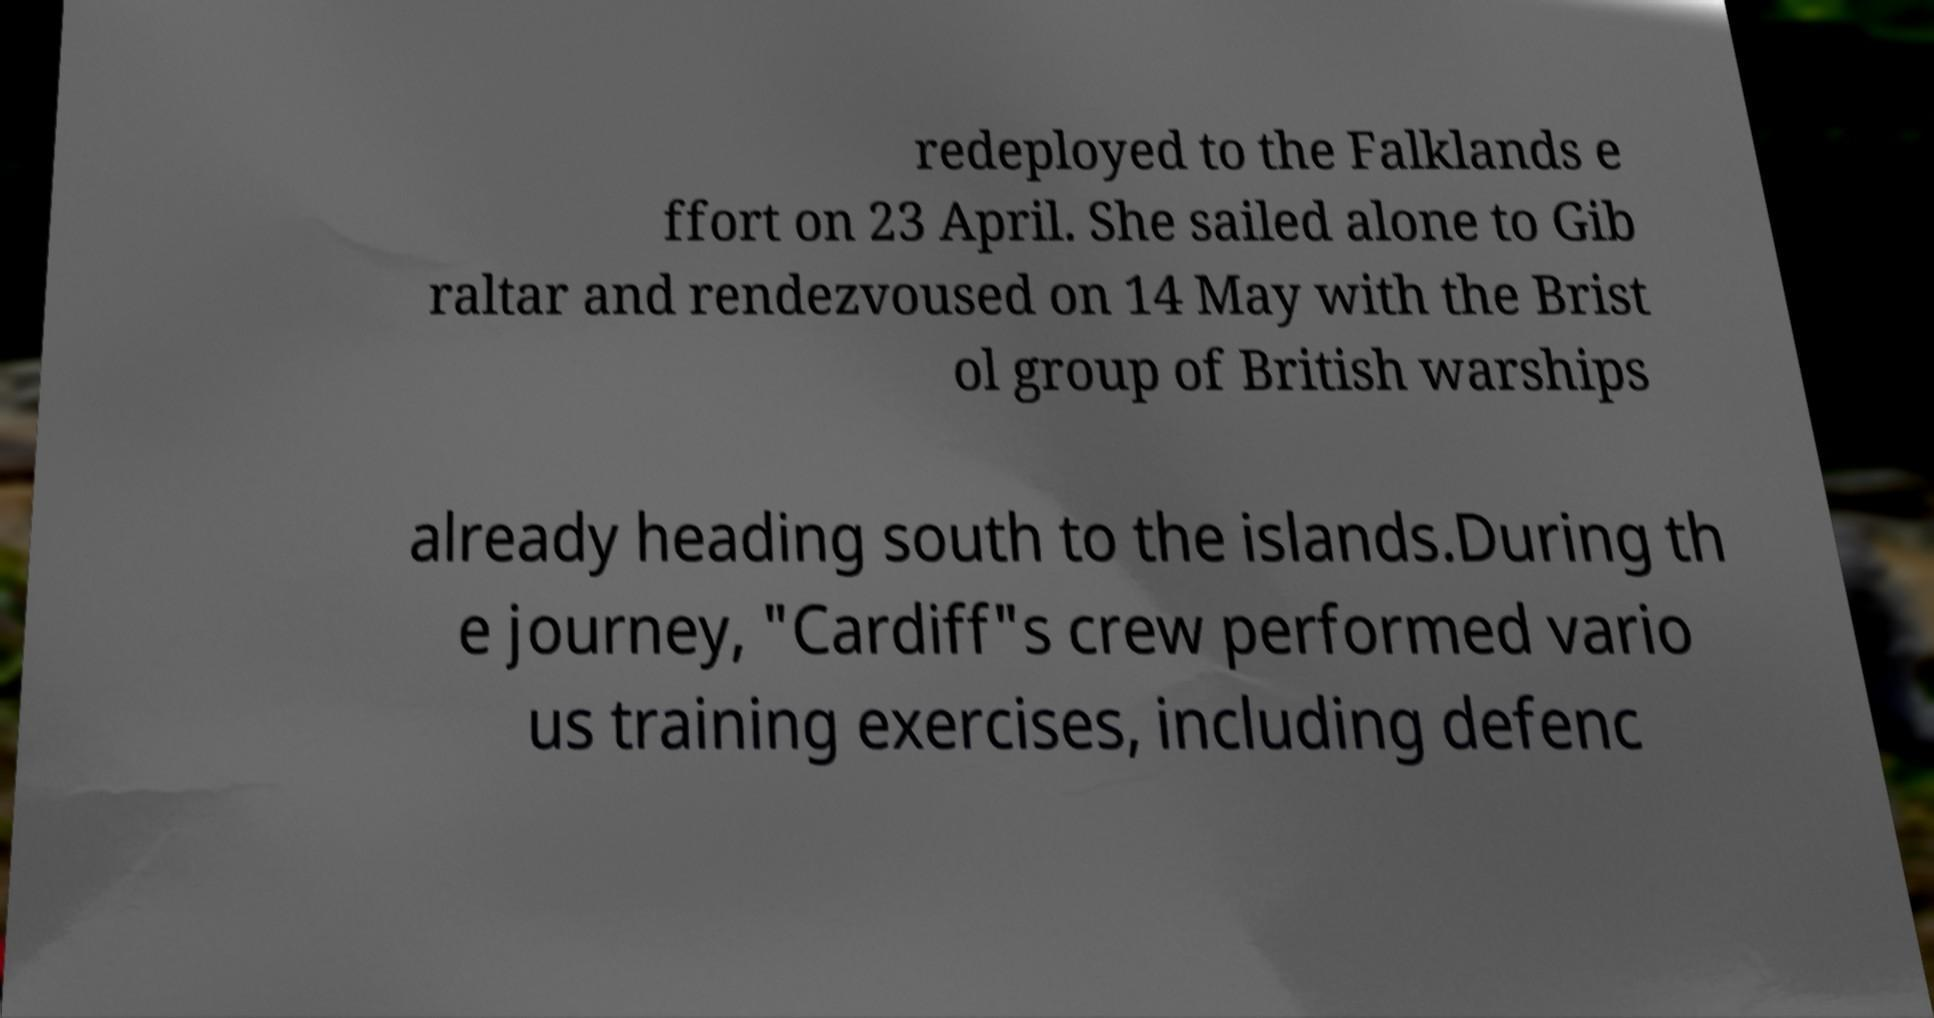Please read and relay the text visible in this image. What does it say? redeployed to the Falklands e ffort on 23 April. She sailed alone to Gib raltar and rendezvoused on 14 May with the Brist ol group of British warships already heading south to the islands.During th e journey, "Cardiff"s crew performed vario us training exercises, including defenc 